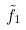<formula> <loc_0><loc_0><loc_500><loc_500>\tilde { f } _ { 1 }</formula> 